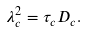<formula> <loc_0><loc_0><loc_500><loc_500>\lambda _ { c } ^ { 2 } = \tau _ { c } D _ { c } .</formula> 